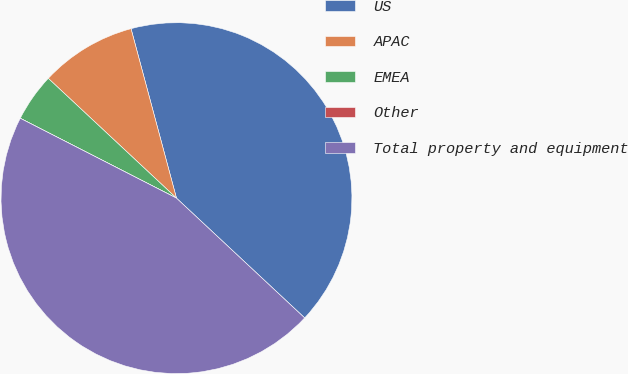Convert chart to OTSL. <chart><loc_0><loc_0><loc_500><loc_500><pie_chart><fcel>US<fcel>APAC<fcel>EMEA<fcel>Other<fcel>Total property and equipment<nl><fcel>41.13%<fcel>8.87%<fcel>4.44%<fcel>0.0%<fcel>45.56%<nl></chart> 